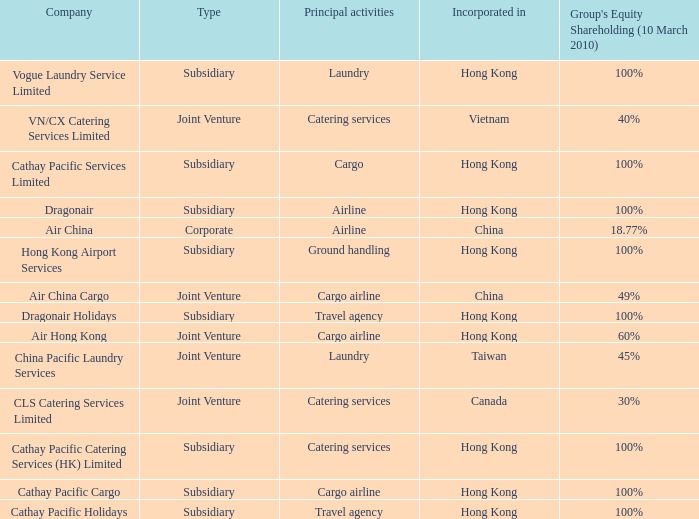What is the name of the company that has a Group's equity shareholding percentage, as of March 10th, 2010, of 100%, as well as a Principal activity of Airline? Dragonair. 